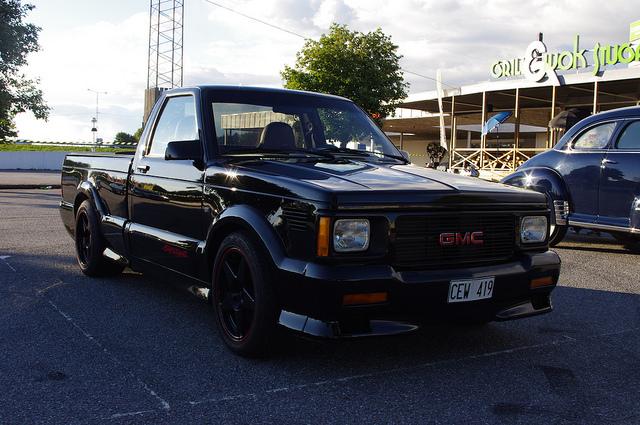Is this truck going anywhere?
Be succinct. No. What color is the truck?
Quick response, please. Black. What brand is the truck?
Quick response, please. Gmc. 